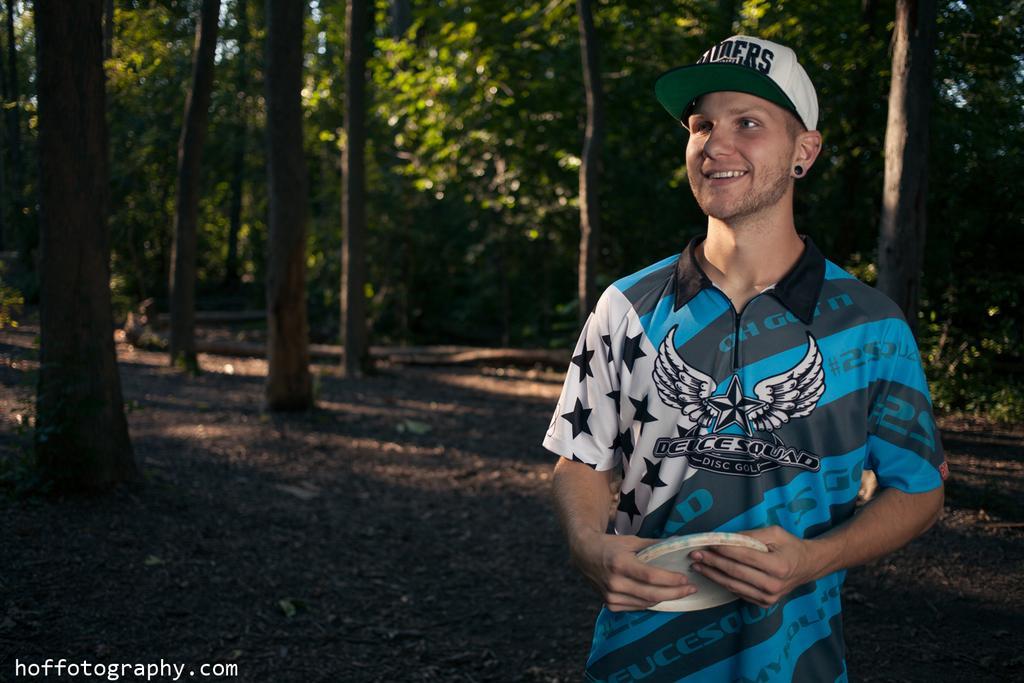In one or two sentences, can you explain what this image depicts? In the foreground of the image there is a person wearing a cap. In the background of the image there are trees. At the bottom of the image there is soil and text. 